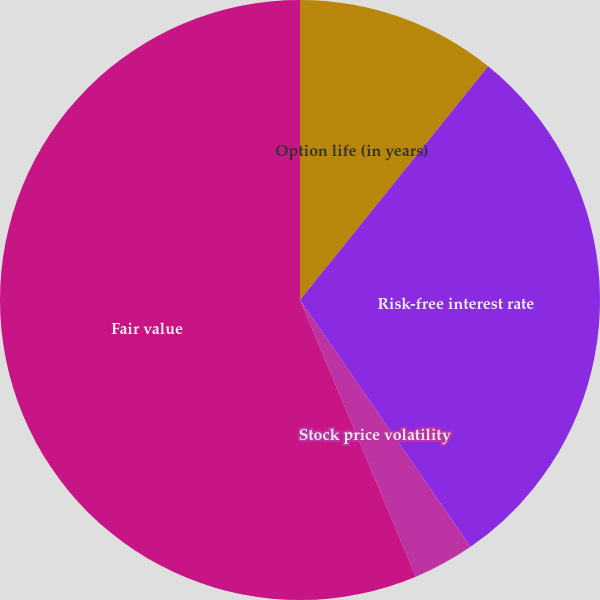Convert chart. <chart><loc_0><loc_0><loc_500><loc_500><pie_chart><fcel>Option life (in years)<fcel>Risk-free interest rate<fcel>Stock price volatility<fcel>Fair value<nl><fcel>10.79%<fcel>29.59%<fcel>3.31%<fcel>56.31%<nl></chart> 